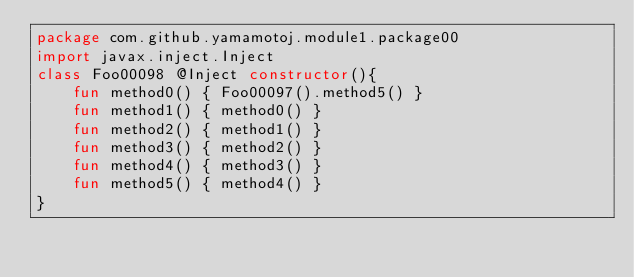<code> <loc_0><loc_0><loc_500><loc_500><_Kotlin_>package com.github.yamamotoj.module1.package00
import javax.inject.Inject
class Foo00098 @Inject constructor(){
    fun method0() { Foo00097().method5() }
    fun method1() { method0() }
    fun method2() { method1() }
    fun method3() { method2() }
    fun method4() { method3() }
    fun method5() { method4() }
}
</code> 